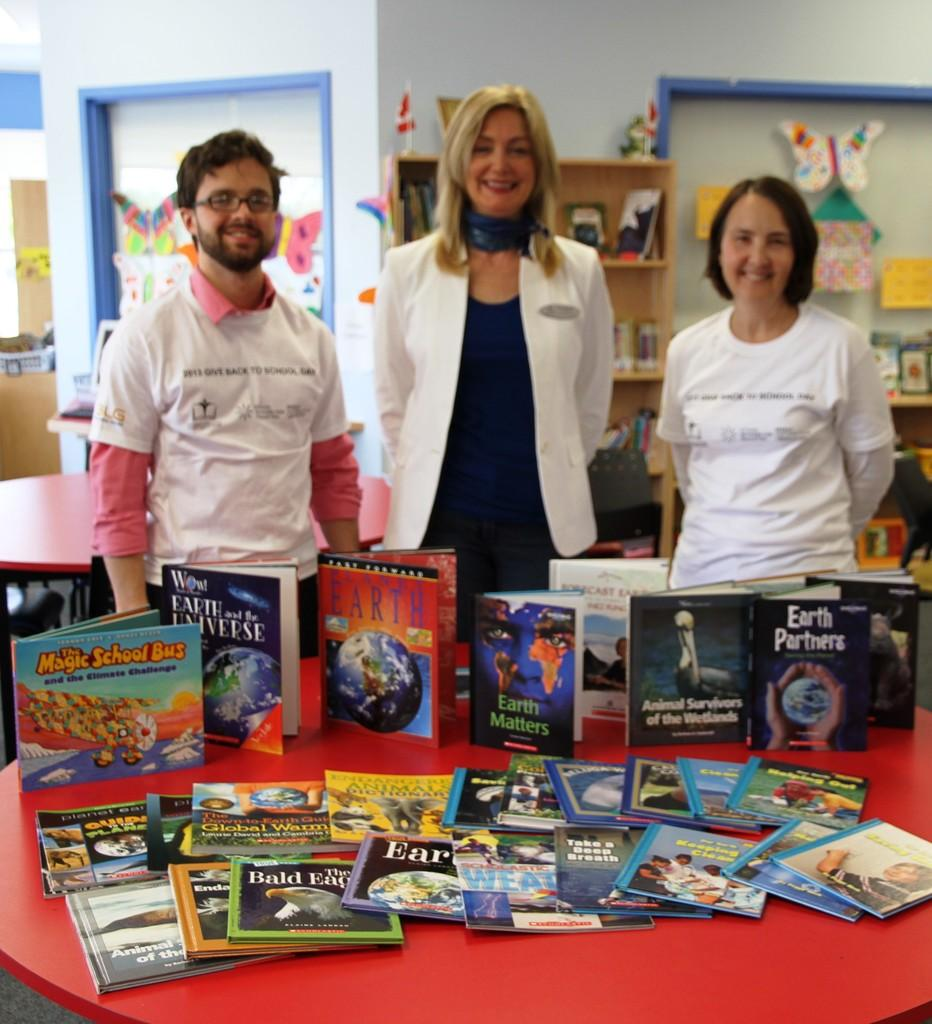<image>
Relay a brief, clear account of the picture shown. People standing behind a display of books about topics such as animals, the environment, and planet earth. 